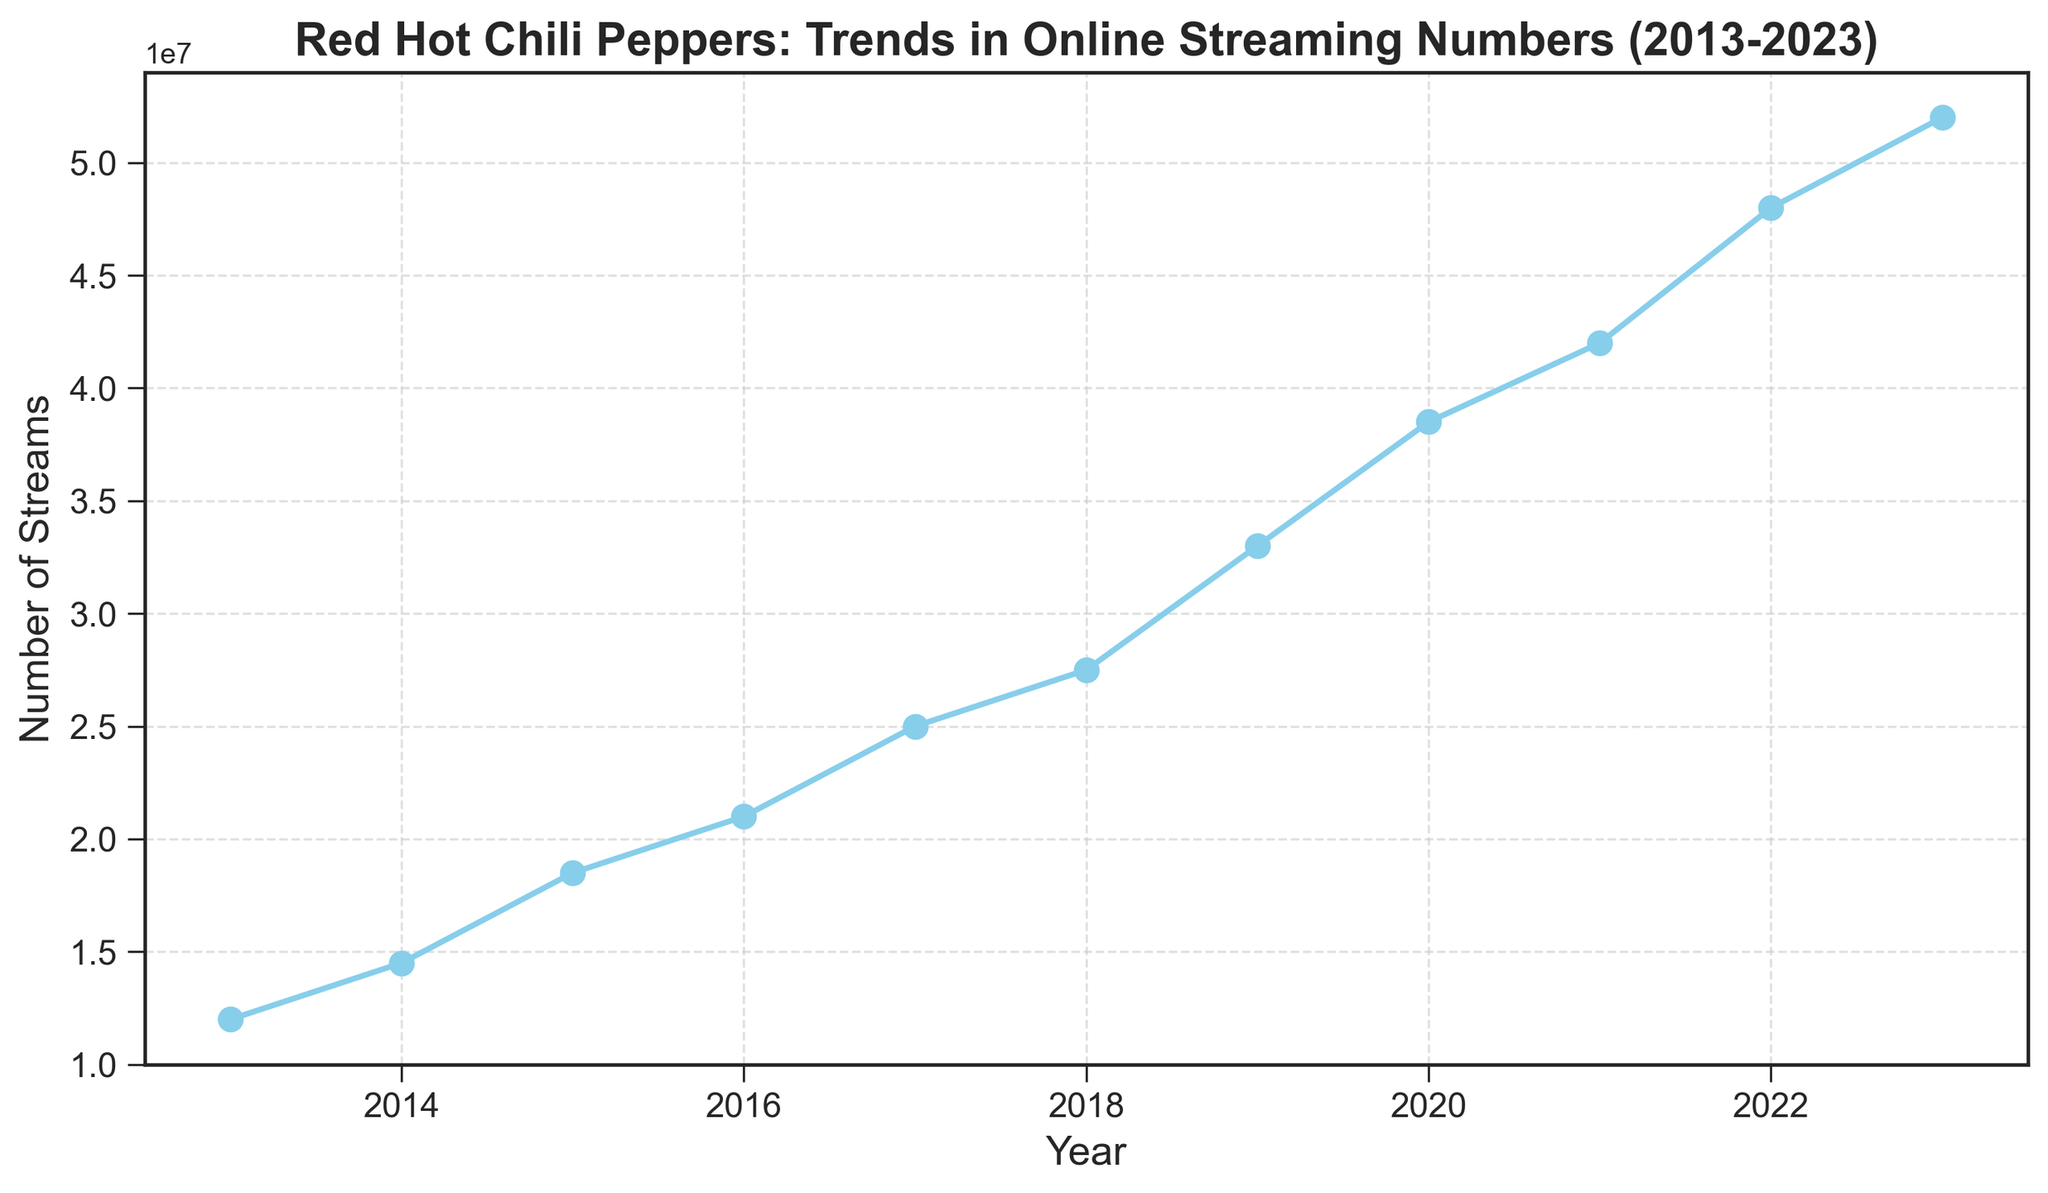What is the overall trend in the number of streams for Red Hot Chili Peppers' songs from 2013 to 2023? The overall trend shows a consistent increase in the number of streams for Red Hot Chili Peppers' songs over the years. Starting at 12 million streams in 2013, it steadily rises each year, reaching 52 million streams in 2023. This indicates a growing popularity and increased online streaming of their music.
Answer: Consistent increase In which year did the Red Hot Chili Peppers see the largest single-year increase in streams? To find the largest single-year increase, subtract the number of streams of each year from the subsequent year to get the differences. The largest single-year increase occurred between 2019 and 2020, where the difference is 55 million - 33 million = 5.5 million streams.
Answer: 2020 What is the average number of streams per year from 2013 to 2023? To find the average number of streams per year, sum the total number of streams over the years and divide by the number of years. The sum is 12+14.5+18.5+21+25+27.5+33+38.5+42+48+52 = 320. Divide by 11 (years), the average is 320/11 ≈ 29.09 million.
Answer: 29.09 million Would you say the growth in streaming numbers was steady or did it fluctuate? By looking at the plot, the line representing the data points rises steadily without significant dips or sharp rises, although the magnitude of the increase slightly varies year to year, indicating relatively steady growth without major fluctuations.
Answer: Steady growth In which year did the streaming numbers surpass 30 million for the first time? To find the year when the streaming numbers first surpassed 30 million, observe the plot and locate the year where the streams exceed 30 million. In 2019, the streams reached 33 million, surpassing 30 million for the first time.
Answer: 2019 Compare the number of streams in 2014 and 2018. How much more popular did the Red Hot Chili Peppers become over these years measured by increase in streams? Observing the plot, in 2014, there are 14.5 million streams and in 2018, there are 27.5 million streams. The increase in streams is 27.5 - 14.5 = 13 million, indicating a significant increase in popularity over these years.
Answer: 13 million How many times greater were the streams in 2023 compared to 2013? To find how many times greater the streams in 2023 are compared to 2013, divide the number of streams in 2023 by the number in 2013. 52 million / 12 million ≈ 4.33 times.
Answer: 4.33 times How would you describe the visual style of the plot? The visual style of the plot uses a line with circles marking each data point. The color of the line is sky blue with a smooth line connecting the points, creating a visually appealing and easily interpretable figure. The gridlines add clarity to the reading of the plot.
Answer: Line plot with sky blue color and gridlines Between which two consecutive years did the Red Hot Chili Peppers see the smallest increase in streaming numbers? To identify the smallest increase, calculate the differences between consecutive years. The smallest increase occurred between 2017 and 2018, with the change being 27.5 million - 25 million = 2.5 million.
Answer: 2017 and 2018 From 2013 to 2023, how many times did the streaming numbers increase by more than 5 million in a single year? By examining year-over-year increases on the plot, we see increases exceeding 5 million streams between 2018-2019, 2019-2020, and 2021-2022. Therefore, streaming numbers increased by more than 5 million in a single year 3 times.
Answer: 3 times 